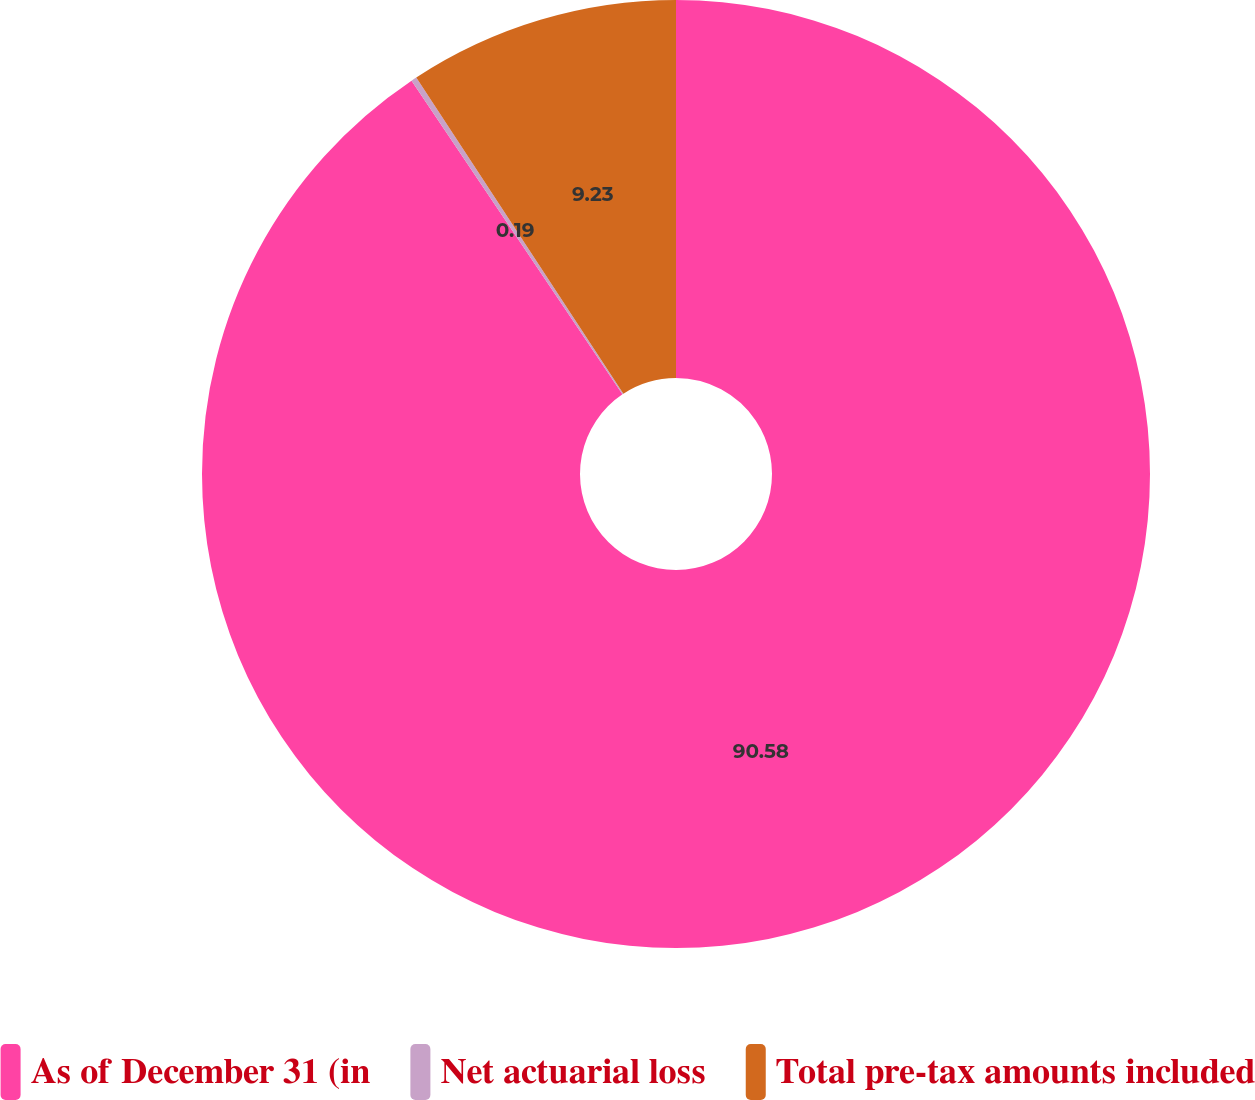Convert chart to OTSL. <chart><loc_0><loc_0><loc_500><loc_500><pie_chart><fcel>As of December 31 (in<fcel>Net actuarial loss<fcel>Total pre-tax amounts included<nl><fcel>90.58%<fcel>0.19%<fcel>9.23%<nl></chart> 